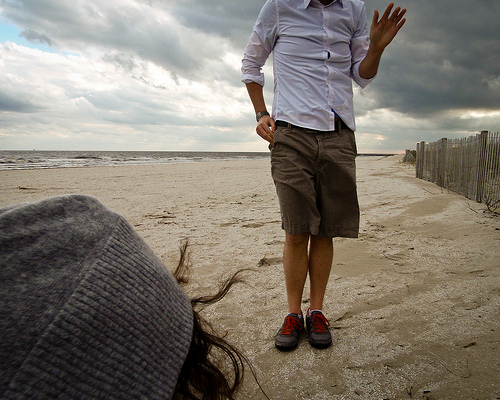<image>
Is there a cloth behind the man? No. The cloth is not behind the man. From this viewpoint, the cloth appears to be positioned elsewhere in the scene. 